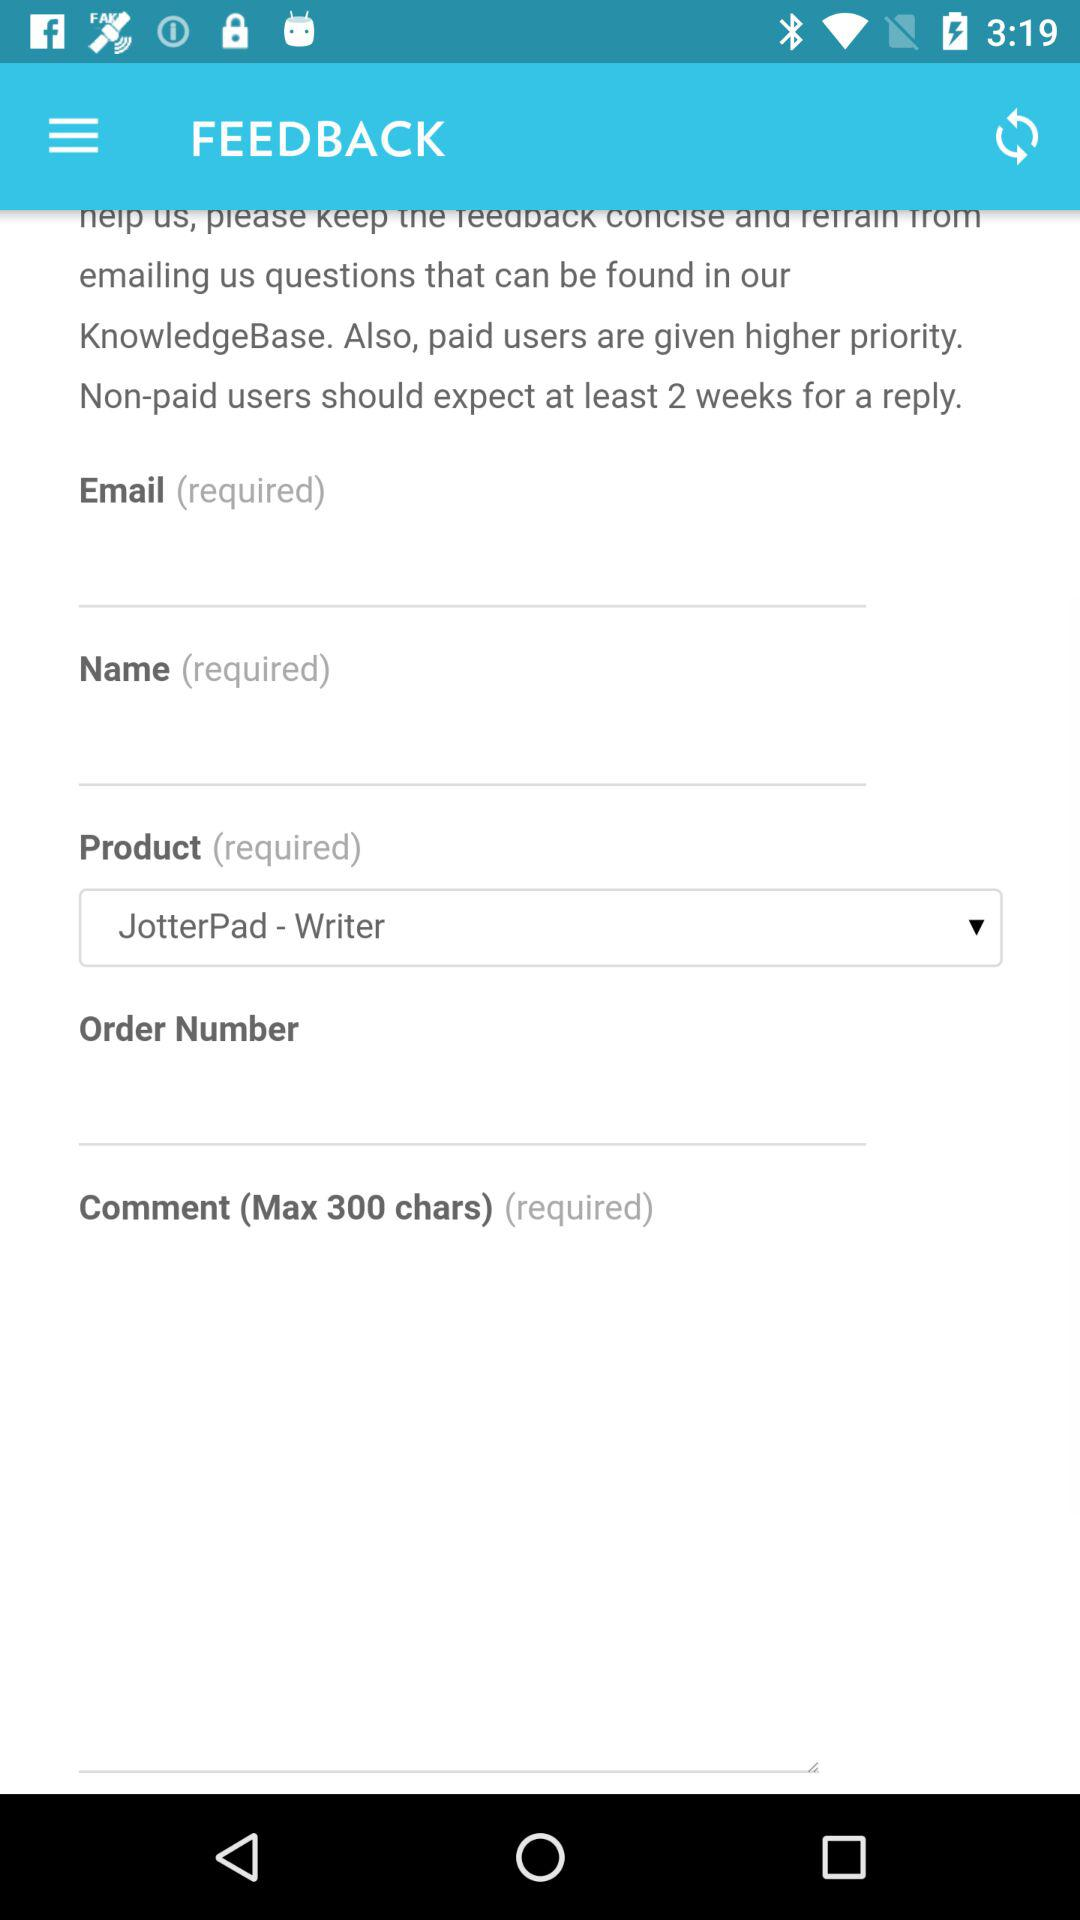What is the maximum number of characters for writing a comment? The maximum number of characters for writing a comment is 300. 